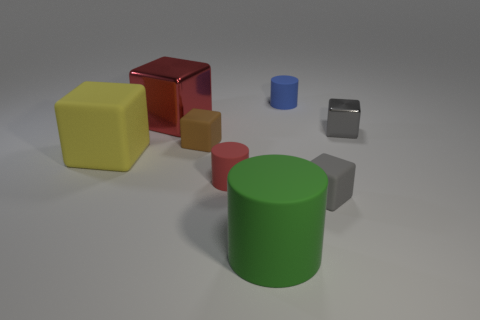Subtract all red blocks. How many blocks are left? 4 Subtract all gray matte cubes. How many cubes are left? 4 Subtract all brown blocks. Subtract all yellow balls. How many blocks are left? 4 Add 2 gray shiny blocks. How many objects exist? 10 Subtract all cubes. How many objects are left? 3 Subtract 1 brown blocks. How many objects are left? 7 Subtract all brown matte cubes. Subtract all brown rubber blocks. How many objects are left? 6 Add 8 small red rubber cylinders. How many small red rubber cylinders are left? 9 Add 8 red cylinders. How many red cylinders exist? 9 